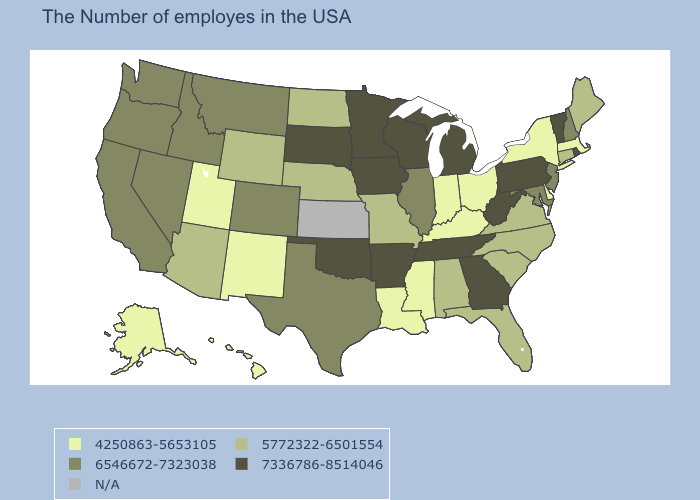Name the states that have a value in the range 4250863-5653105?
Keep it brief. Massachusetts, New York, Delaware, Ohio, Kentucky, Indiana, Mississippi, Louisiana, New Mexico, Utah, Alaska, Hawaii. Which states have the lowest value in the West?
Concise answer only. New Mexico, Utah, Alaska, Hawaii. Among the states that border California , does Arizona have the highest value?
Keep it brief. No. Which states hav the highest value in the South?
Give a very brief answer. West Virginia, Georgia, Tennessee, Arkansas, Oklahoma. Does Massachusetts have the lowest value in the USA?
Keep it brief. Yes. Is the legend a continuous bar?
Give a very brief answer. No. Name the states that have a value in the range 5772322-6501554?
Answer briefly. Maine, Connecticut, Virginia, North Carolina, South Carolina, Florida, Alabama, Missouri, Nebraska, North Dakota, Wyoming, Arizona. Does North Dakota have the highest value in the MidWest?
Be succinct. No. Is the legend a continuous bar?
Be succinct. No. Name the states that have a value in the range N/A?
Be succinct. Kansas. Is the legend a continuous bar?
Answer briefly. No. Does the map have missing data?
Be succinct. Yes. Does Nebraska have the lowest value in the MidWest?
Be succinct. No. What is the value of Oklahoma?
Short answer required. 7336786-8514046. 